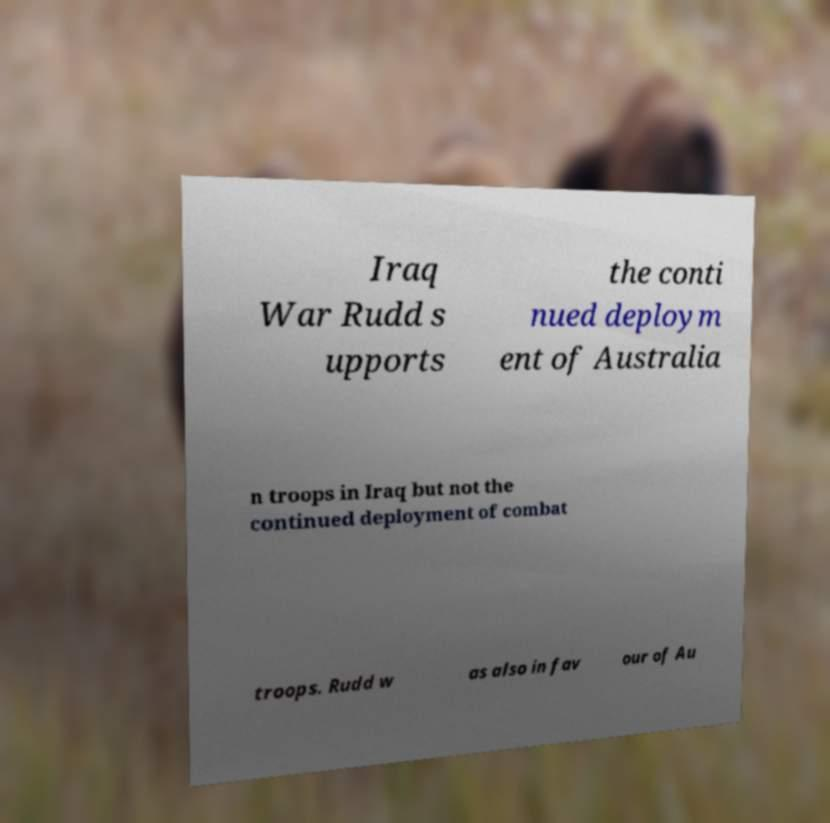Please identify and transcribe the text found in this image. Iraq War Rudd s upports the conti nued deploym ent of Australia n troops in Iraq but not the continued deployment of combat troops. Rudd w as also in fav our of Au 